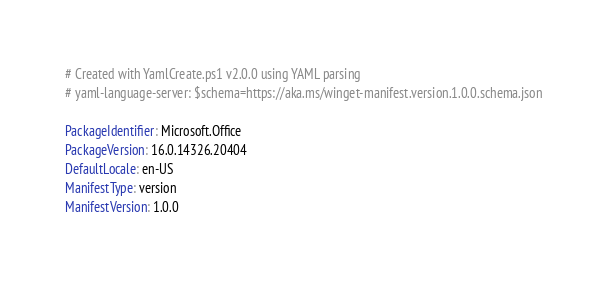Convert code to text. <code><loc_0><loc_0><loc_500><loc_500><_YAML_># Created with YamlCreate.ps1 v2.0.0 using YAML parsing
# yaml-language-server: $schema=https://aka.ms/winget-manifest.version.1.0.0.schema.json

PackageIdentifier: Microsoft.Office
PackageVersion: 16.0.14326.20404
DefaultLocale: en-US
ManifestType: version
ManifestVersion: 1.0.0
</code> 